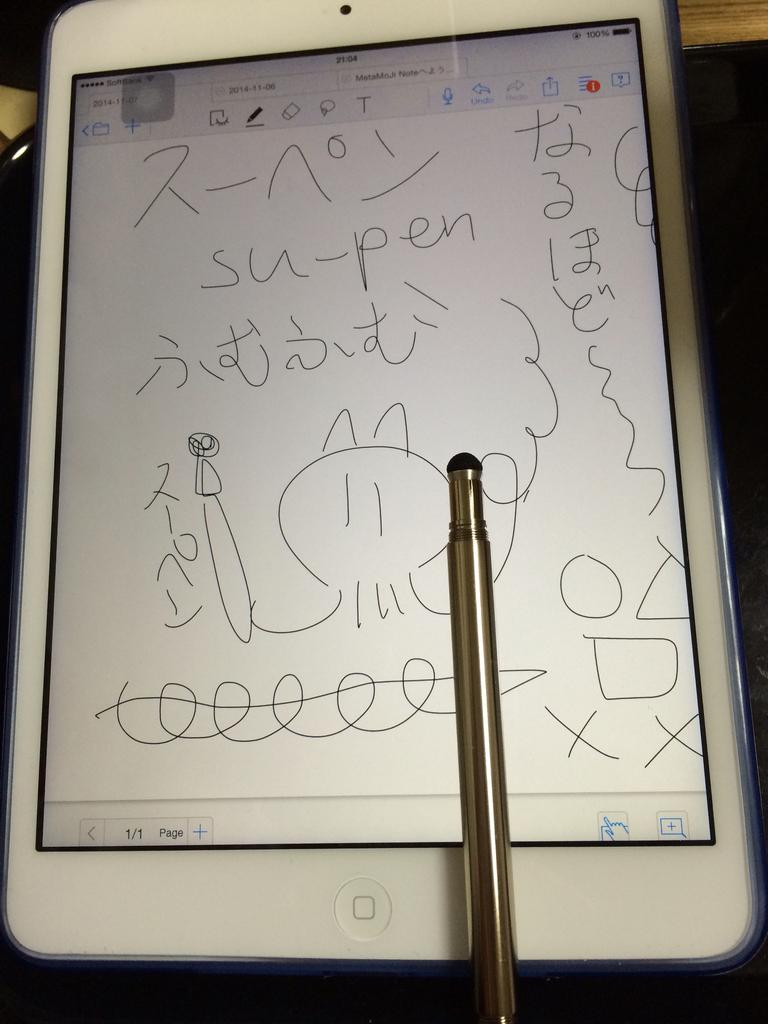What electronic device is visible in the image? There is a smartphone in the image. What accessory is present alongside the smartphone? There is a smartphone pen in the image. What type of bird is playing the guitar in the image? There is no bird or guitar present in the image. 